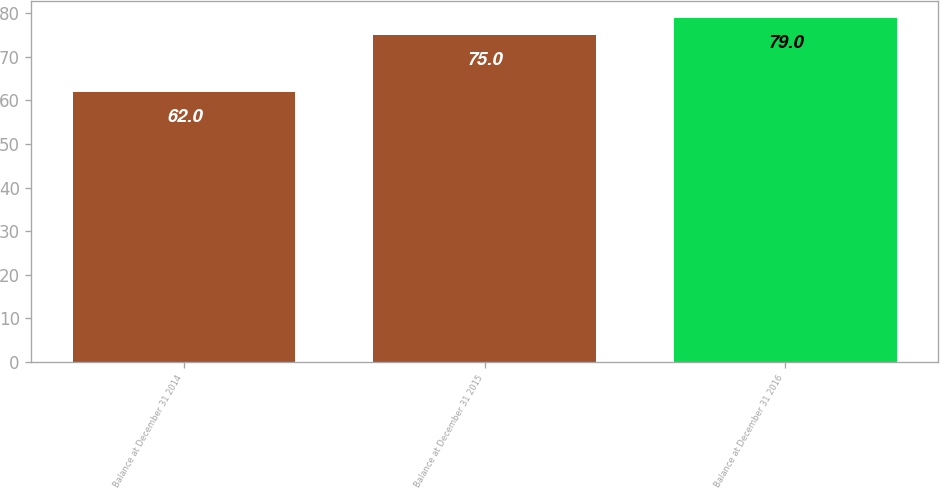Convert chart to OTSL. <chart><loc_0><loc_0><loc_500><loc_500><bar_chart><fcel>Balance at December 31 2014<fcel>Balance at December 31 2015<fcel>Balance at December 31 2016<nl><fcel>62<fcel>75<fcel>79<nl></chart> 